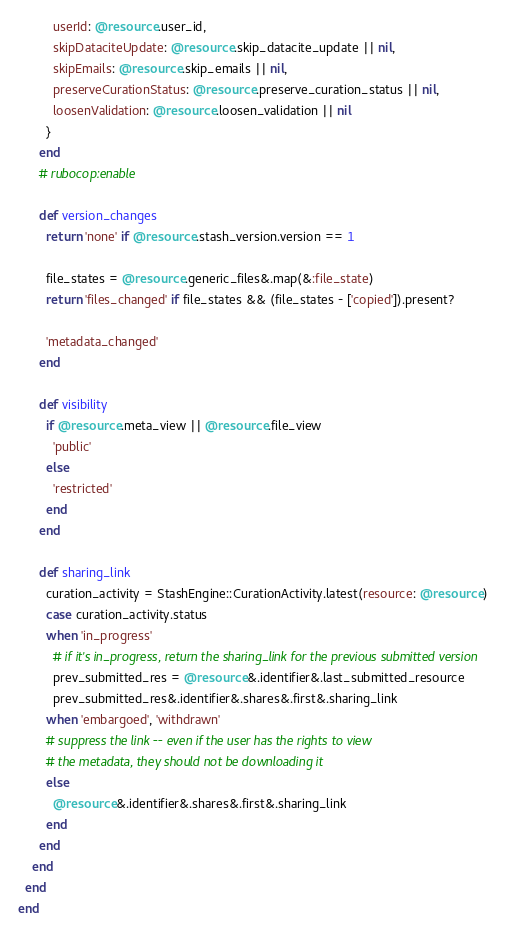<code> <loc_0><loc_0><loc_500><loc_500><_Ruby_>          userId: @resource.user_id,
          skipDataciteUpdate: @resource.skip_datacite_update || nil,
          skipEmails: @resource.skip_emails || nil,
          preserveCurationStatus: @resource.preserve_curation_status || nil,
          loosenValidation: @resource.loosen_validation || nil
        }
      end
      # rubocop:enable

      def version_changes
        return 'none' if @resource.stash_version.version == 1

        file_states = @resource.generic_files&.map(&:file_state)
        return 'files_changed' if file_states && (file_states - ['copied']).present?

        'metadata_changed'
      end

      def visibility
        if @resource.meta_view || @resource.file_view
          'public'
        else
          'restricted'
        end
      end

      def sharing_link
        curation_activity = StashEngine::CurationActivity.latest(resource: @resource)
        case curation_activity.status
        when 'in_progress'
          # if it's in_progress, return the sharing_link for the previous submitted version
          prev_submitted_res = @resource&.identifier&.last_submitted_resource
          prev_submitted_res&.identifier&.shares&.first&.sharing_link
        when 'embargoed', 'withdrawn'
        # suppress the link -- even if the user has the rights to view
        # the metadata, they should not be downloading it
        else
          @resource&.identifier&.shares&.first&.sharing_link
        end
      end
    end
  end
end
</code> 